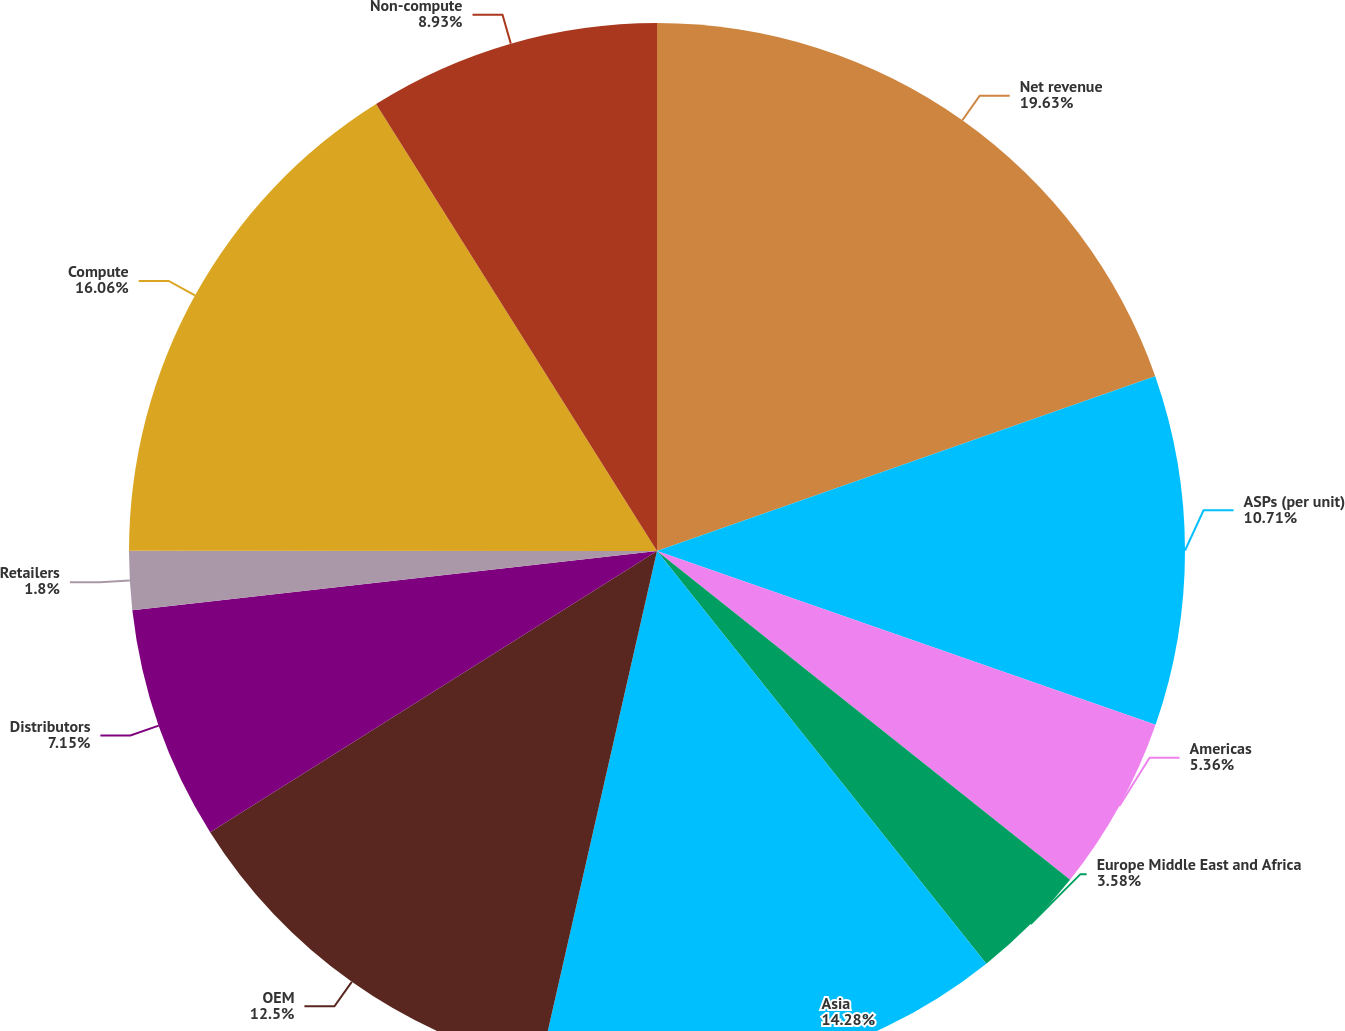Convert chart to OTSL. <chart><loc_0><loc_0><loc_500><loc_500><pie_chart><fcel>Net revenue<fcel>ASPs (per unit)<fcel>Americas<fcel>Europe Middle East and Africa<fcel>Asia<fcel>OEM<fcel>Distributors<fcel>Retailers<fcel>Compute<fcel>Non-compute<nl><fcel>19.63%<fcel>10.71%<fcel>5.36%<fcel>3.58%<fcel>14.28%<fcel>12.5%<fcel>7.15%<fcel>1.8%<fcel>16.06%<fcel>8.93%<nl></chart> 